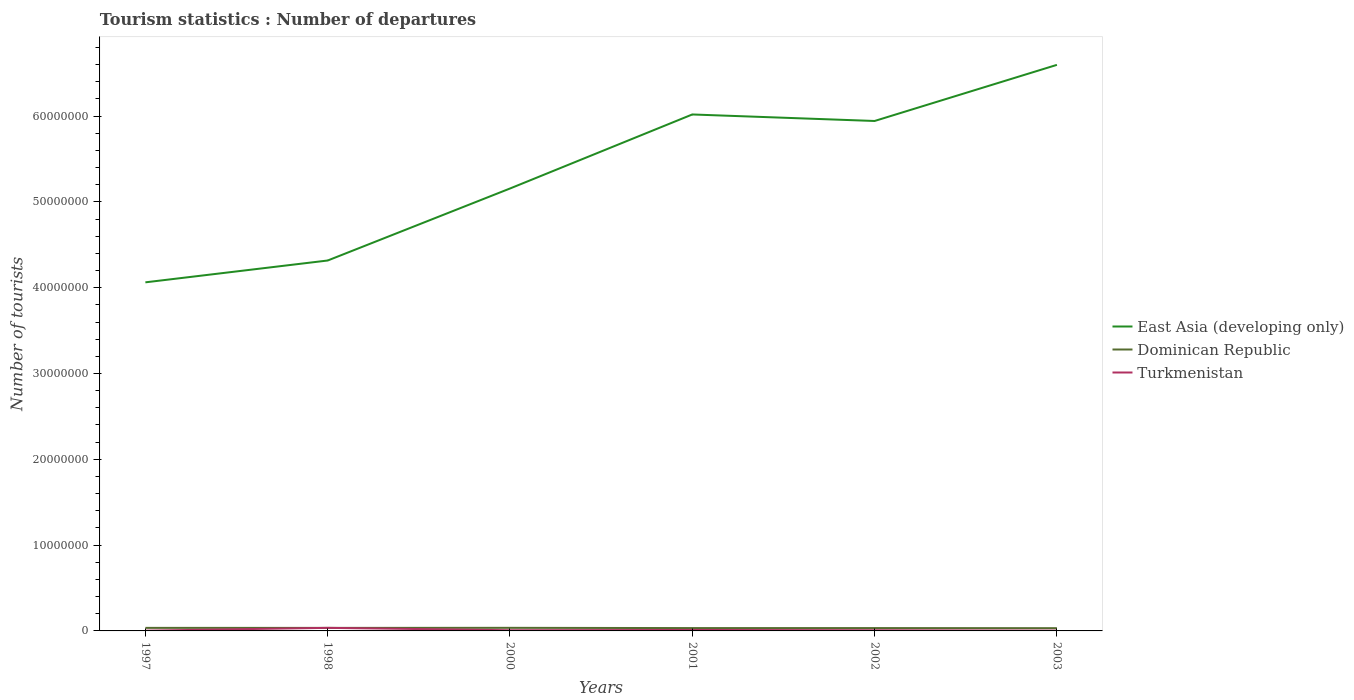Across all years, what is the maximum number of tourist departures in Turkmenistan?
Ensure brevity in your answer.  3.10e+04. What is the total number of tourist departures in East Asia (developing only) in the graph?
Offer a very short reply. -8.63e+06. What is the difference between the highest and the second highest number of tourist departures in Dominican Republic?
Offer a very short reply. 3.90e+04. What is the difference between the highest and the lowest number of tourist departures in East Asia (developing only)?
Your answer should be very brief. 3. What is the difference between two consecutive major ticks on the Y-axis?
Your answer should be very brief. 1.00e+07. Where does the legend appear in the graph?
Make the answer very short. Center right. How many legend labels are there?
Ensure brevity in your answer.  3. What is the title of the graph?
Your response must be concise. Tourism statistics : Number of departures. Does "West Bank and Gaza" appear as one of the legend labels in the graph?
Ensure brevity in your answer.  No. What is the label or title of the X-axis?
Your answer should be very brief. Years. What is the label or title of the Y-axis?
Your answer should be compact. Number of tourists. What is the Number of tourists of East Asia (developing only) in 1997?
Your response must be concise. 4.06e+07. What is the Number of tourists of Dominican Republic in 1997?
Your response must be concise. 3.55e+05. What is the Number of tourists of Turkmenistan in 1997?
Your answer should be very brief. 3.10e+04. What is the Number of tourists in East Asia (developing only) in 1998?
Your answer should be compact. 4.32e+07. What is the Number of tourists in Dominican Republic in 1998?
Offer a terse response. 3.54e+05. What is the Number of tourists of Turkmenistan in 1998?
Give a very brief answer. 3.57e+05. What is the Number of tourists in East Asia (developing only) in 2000?
Ensure brevity in your answer.  5.16e+07. What is the Number of tourists of Turkmenistan in 2000?
Give a very brief answer. 7.80e+04. What is the Number of tourists of East Asia (developing only) in 2001?
Offer a very short reply. 6.02e+07. What is the Number of tourists of Dominican Republic in 2001?
Give a very brief answer. 3.31e+05. What is the Number of tourists of Turkmenistan in 2001?
Your response must be concise. 1.11e+05. What is the Number of tourists in East Asia (developing only) in 2002?
Offer a terse response. 5.94e+07. What is the Number of tourists of Dominican Republic in 2002?
Your answer should be compact. 3.32e+05. What is the Number of tourists of Turkmenistan in 2002?
Give a very brief answer. 7.90e+04. What is the Number of tourists in East Asia (developing only) in 2003?
Your answer should be very brief. 6.60e+07. What is the Number of tourists of Dominican Republic in 2003?
Keep it short and to the point. 3.21e+05. What is the Number of tourists of Turkmenistan in 2003?
Your answer should be compact. 3.40e+04. Across all years, what is the maximum Number of tourists of East Asia (developing only)?
Keep it short and to the point. 6.60e+07. Across all years, what is the maximum Number of tourists of Dominican Republic?
Offer a very short reply. 3.60e+05. Across all years, what is the maximum Number of tourists of Turkmenistan?
Give a very brief answer. 3.57e+05. Across all years, what is the minimum Number of tourists of East Asia (developing only)?
Ensure brevity in your answer.  4.06e+07. Across all years, what is the minimum Number of tourists in Dominican Republic?
Ensure brevity in your answer.  3.21e+05. Across all years, what is the minimum Number of tourists in Turkmenistan?
Keep it short and to the point. 3.10e+04. What is the total Number of tourists of East Asia (developing only) in the graph?
Make the answer very short. 3.21e+08. What is the total Number of tourists in Dominican Republic in the graph?
Your response must be concise. 2.05e+06. What is the total Number of tourists of Turkmenistan in the graph?
Give a very brief answer. 6.90e+05. What is the difference between the Number of tourists in East Asia (developing only) in 1997 and that in 1998?
Offer a terse response. -2.54e+06. What is the difference between the Number of tourists in Turkmenistan in 1997 and that in 1998?
Offer a terse response. -3.26e+05. What is the difference between the Number of tourists of East Asia (developing only) in 1997 and that in 2000?
Provide a short and direct response. -1.09e+07. What is the difference between the Number of tourists in Dominican Republic in 1997 and that in 2000?
Give a very brief answer. -5000. What is the difference between the Number of tourists of Turkmenistan in 1997 and that in 2000?
Make the answer very short. -4.70e+04. What is the difference between the Number of tourists in East Asia (developing only) in 1997 and that in 2001?
Make the answer very short. -1.96e+07. What is the difference between the Number of tourists of Dominican Republic in 1997 and that in 2001?
Your response must be concise. 2.40e+04. What is the difference between the Number of tourists of Turkmenistan in 1997 and that in 2001?
Your answer should be very brief. -8.00e+04. What is the difference between the Number of tourists in East Asia (developing only) in 1997 and that in 2002?
Your answer should be very brief. -1.88e+07. What is the difference between the Number of tourists in Dominican Republic in 1997 and that in 2002?
Your response must be concise. 2.30e+04. What is the difference between the Number of tourists of Turkmenistan in 1997 and that in 2002?
Ensure brevity in your answer.  -4.80e+04. What is the difference between the Number of tourists of East Asia (developing only) in 1997 and that in 2003?
Your response must be concise. -2.53e+07. What is the difference between the Number of tourists in Dominican Republic in 1997 and that in 2003?
Ensure brevity in your answer.  3.40e+04. What is the difference between the Number of tourists in Turkmenistan in 1997 and that in 2003?
Ensure brevity in your answer.  -3000. What is the difference between the Number of tourists in East Asia (developing only) in 1998 and that in 2000?
Offer a very short reply. -8.39e+06. What is the difference between the Number of tourists in Dominican Republic in 1998 and that in 2000?
Your answer should be compact. -6000. What is the difference between the Number of tourists of Turkmenistan in 1998 and that in 2000?
Offer a very short reply. 2.79e+05. What is the difference between the Number of tourists in East Asia (developing only) in 1998 and that in 2001?
Provide a succinct answer. -1.70e+07. What is the difference between the Number of tourists in Dominican Republic in 1998 and that in 2001?
Give a very brief answer. 2.30e+04. What is the difference between the Number of tourists of Turkmenistan in 1998 and that in 2001?
Your response must be concise. 2.46e+05. What is the difference between the Number of tourists in East Asia (developing only) in 1998 and that in 2002?
Keep it short and to the point. -1.63e+07. What is the difference between the Number of tourists of Dominican Republic in 1998 and that in 2002?
Your answer should be compact. 2.20e+04. What is the difference between the Number of tourists of Turkmenistan in 1998 and that in 2002?
Make the answer very short. 2.78e+05. What is the difference between the Number of tourists in East Asia (developing only) in 1998 and that in 2003?
Keep it short and to the point. -2.28e+07. What is the difference between the Number of tourists in Dominican Republic in 1998 and that in 2003?
Ensure brevity in your answer.  3.30e+04. What is the difference between the Number of tourists in Turkmenistan in 1998 and that in 2003?
Your response must be concise. 3.23e+05. What is the difference between the Number of tourists of East Asia (developing only) in 2000 and that in 2001?
Offer a terse response. -8.63e+06. What is the difference between the Number of tourists in Dominican Republic in 2000 and that in 2001?
Your response must be concise. 2.90e+04. What is the difference between the Number of tourists of Turkmenistan in 2000 and that in 2001?
Your answer should be compact. -3.30e+04. What is the difference between the Number of tourists of East Asia (developing only) in 2000 and that in 2002?
Offer a terse response. -7.87e+06. What is the difference between the Number of tourists of Dominican Republic in 2000 and that in 2002?
Your answer should be very brief. 2.80e+04. What is the difference between the Number of tourists of Turkmenistan in 2000 and that in 2002?
Your answer should be very brief. -1000. What is the difference between the Number of tourists of East Asia (developing only) in 2000 and that in 2003?
Your response must be concise. -1.44e+07. What is the difference between the Number of tourists in Dominican Republic in 2000 and that in 2003?
Keep it short and to the point. 3.90e+04. What is the difference between the Number of tourists of Turkmenistan in 2000 and that in 2003?
Ensure brevity in your answer.  4.40e+04. What is the difference between the Number of tourists of East Asia (developing only) in 2001 and that in 2002?
Offer a very short reply. 7.60e+05. What is the difference between the Number of tourists in Dominican Republic in 2001 and that in 2002?
Give a very brief answer. -1000. What is the difference between the Number of tourists of Turkmenistan in 2001 and that in 2002?
Provide a succinct answer. 3.20e+04. What is the difference between the Number of tourists in East Asia (developing only) in 2001 and that in 2003?
Ensure brevity in your answer.  -5.78e+06. What is the difference between the Number of tourists in Turkmenistan in 2001 and that in 2003?
Provide a succinct answer. 7.70e+04. What is the difference between the Number of tourists of East Asia (developing only) in 2002 and that in 2003?
Ensure brevity in your answer.  -6.54e+06. What is the difference between the Number of tourists of Dominican Republic in 2002 and that in 2003?
Ensure brevity in your answer.  1.10e+04. What is the difference between the Number of tourists of Turkmenistan in 2002 and that in 2003?
Provide a short and direct response. 4.50e+04. What is the difference between the Number of tourists in East Asia (developing only) in 1997 and the Number of tourists in Dominican Republic in 1998?
Provide a succinct answer. 4.03e+07. What is the difference between the Number of tourists of East Asia (developing only) in 1997 and the Number of tourists of Turkmenistan in 1998?
Your answer should be very brief. 4.03e+07. What is the difference between the Number of tourists in Dominican Republic in 1997 and the Number of tourists in Turkmenistan in 1998?
Ensure brevity in your answer.  -2000. What is the difference between the Number of tourists of East Asia (developing only) in 1997 and the Number of tourists of Dominican Republic in 2000?
Give a very brief answer. 4.03e+07. What is the difference between the Number of tourists of East Asia (developing only) in 1997 and the Number of tourists of Turkmenistan in 2000?
Provide a succinct answer. 4.05e+07. What is the difference between the Number of tourists of Dominican Republic in 1997 and the Number of tourists of Turkmenistan in 2000?
Offer a very short reply. 2.77e+05. What is the difference between the Number of tourists in East Asia (developing only) in 1997 and the Number of tourists in Dominican Republic in 2001?
Ensure brevity in your answer.  4.03e+07. What is the difference between the Number of tourists in East Asia (developing only) in 1997 and the Number of tourists in Turkmenistan in 2001?
Keep it short and to the point. 4.05e+07. What is the difference between the Number of tourists of Dominican Republic in 1997 and the Number of tourists of Turkmenistan in 2001?
Your answer should be very brief. 2.44e+05. What is the difference between the Number of tourists of East Asia (developing only) in 1997 and the Number of tourists of Dominican Republic in 2002?
Provide a succinct answer. 4.03e+07. What is the difference between the Number of tourists of East Asia (developing only) in 1997 and the Number of tourists of Turkmenistan in 2002?
Your response must be concise. 4.05e+07. What is the difference between the Number of tourists in Dominican Republic in 1997 and the Number of tourists in Turkmenistan in 2002?
Keep it short and to the point. 2.76e+05. What is the difference between the Number of tourists in East Asia (developing only) in 1997 and the Number of tourists in Dominican Republic in 2003?
Your answer should be compact. 4.03e+07. What is the difference between the Number of tourists of East Asia (developing only) in 1997 and the Number of tourists of Turkmenistan in 2003?
Keep it short and to the point. 4.06e+07. What is the difference between the Number of tourists of Dominican Republic in 1997 and the Number of tourists of Turkmenistan in 2003?
Give a very brief answer. 3.21e+05. What is the difference between the Number of tourists of East Asia (developing only) in 1998 and the Number of tourists of Dominican Republic in 2000?
Your response must be concise. 4.28e+07. What is the difference between the Number of tourists in East Asia (developing only) in 1998 and the Number of tourists in Turkmenistan in 2000?
Offer a very short reply. 4.31e+07. What is the difference between the Number of tourists of Dominican Republic in 1998 and the Number of tourists of Turkmenistan in 2000?
Provide a succinct answer. 2.76e+05. What is the difference between the Number of tourists in East Asia (developing only) in 1998 and the Number of tourists in Dominican Republic in 2001?
Give a very brief answer. 4.28e+07. What is the difference between the Number of tourists in East Asia (developing only) in 1998 and the Number of tourists in Turkmenistan in 2001?
Your answer should be compact. 4.31e+07. What is the difference between the Number of tourists in Dominican Republic in 1998 and the Number of tourists in Turkmenistan in 2001?
Provide a short and direct response. 2.43e+05. What is the difference between the Number of tourists in East Asia (developing only) in 1998 and the Number of tourists in Dominican Republic in 2002?
Offer a very short reply. 4.28e+07. What is the difference between the Number of tourists in East Asia (developing only) in 1998 and the Number of tourists in Turkmenistan in 2002?
Keep it short and to the point. 4.31e+07. What is the difference between the Number of tourists in Dominican Republic in 1998 and the Number of tourists in Turkmenistan in 2002?
Offer a very short reply. 2.75e+05. What is the difference between the Number of tourists of East Asia (developing only) in 1998 and the Number of tourists of Dominican Republic in 2003?
Offer a very short reply. 4.28e+07. What is the difference between the Number of tourists in East Asia (developing only) in 1998 and the Number of tourists in Turkmenistan in 2003?
Ensure brevity in your answer.  4.31e+07. What is the difference between the Number of tourists of Dominican Republic in 1998 and the Number of tourists of Turkmenistan in 2003?
Give a very brief answer. 3.20e+05. What is the difference between the Number of tourists in East Asia (developing only) in 2000 and the Number of tourists in Dominican Republic in 2001?
Offer a very short reply. 5.12e+07. What is the difference between the Number of tourists in East Asia (developing only) in 2000 and the Number of tourists in Turkmenistan in 2001?
Offer a very short reply. 5.14e+07. What is the difference between the Number of tourists of Dominican Republic in 2000 and the Number of tourists of Turkmenistan in 2001?
Your answer should be very brief. 2.49e+05. What is the difference between the Number of tourists in East Asia (developing only) in 2000 and the Number of tourists in Dominican Republic in 2002?
Give a very brief answer. 5.12e+07. What is the difference between the Number of tourists of East Asia (developing only) in 2000 and the Number of tourists of Turkmenistan in 2002?
Ensure brevity in your answer.  5.15e+07. What is the difference between the Number of tourists in Dominican Republic in 2000 and the Number of tourists in Turkmenistan in 2002?
Provide a succinct answer. 2.81e+05. What is the difference between the Number of tourists of East Asia (developing only) in 2000 and the Number of tourists of Dominican Republic in 2003?
Ensure brevity in your answer.  5.12e+07. What is the difference between the Number of tourists in East Asia (developing only) in 2000 and the Number of tourists in Turkmenistan in 2003?
Make the answer very short. 5.15e+07. What is the difference between the Number of tourists of Dominican Republic in 2000 and the Number of tourists of Turkmenistan in 2003?
Keep it short and to the point. 3.26e+05. What is the difference between the Number of tourists in East Asia (developing only) in 2001 and the Number of tourists in Dominican Republic in 2002?
Provide a succinct answer. 5.99e+07. What is the difference between the Number of tourists of East Asia (developing only) in 2001 and the Number of tourists of Turkmenistan in 2002?
Keep it short and to the point. 6.01e+07. What is the difference between the Number of tourists of Dominican Republic in 2001 and the Number of tourists of Turkmenistan in 2002?
Offer a very short reply. 2.52e+05. What is the difference between the Number of tourists of East Asia (developing only) in 2001 and the Number of tourists of Dominican Republic in 2003?
Give a very brief answer. 5.99e+07. What is the difference between the Number of tourists in East Asia (developing only) in 2001 and the Number of tourists in Turkmenistan in 2003?
Your answer should be compact. 6.02e+07. What is the difference between the Number of tourists of Dominican Republic in 2001 and the Number of tourists of Turkmenistan in 2003?
Offer a terse response. 2.97e+05. What is the difference between the Number of tourists in East Asia (developing only) in 2002 and the Number of tourists in Dominican Republic in 2003?
Offer a very short reply. 5.91e+07. What is the difference between the Number of tourists in East Asia (developing only) in 2002 and the Number of tourists in Turkmenistan in 2003?
Your answer should be very brief. 5.94e+07. What is the difference between the Number of tourists of Dominican Republic in 2002 and the Number of tourists of Turkmenistan in 2003?
Provide a short and direct response. 2.98e+05. What is the average Number of tourists in East Asia (developing only) per year?
Make the answer very short. 5.35e+07. What is the average Number of tourists of Dominican Republic per year?
Make the answer very short. 3.42e+05. What is the average Number of tourists in Turkmenistan per year?
Your response must be concise. 1.15e+05. In the year 1997, what is the difference between the Number of tourists of East Asia (developing only) and Number of tourists of Dominican Republic?
Give a very brief answer. 4.03e+07. In the year 1997, what is the difference between the Number of tourists of East Asia (developing only) and Number of tourists of Turkmenistan?
Your response must be concise. 4.06e+07. In the year 1997, what is the difference between the Number of tourists of Dominican Republic and Number of tourists of Turkmenistan?
Offer a terse response. 3.24e+05. In the year 1998, what is the difference between the Number of tourists in East Asia (developing only) and Number of tourists in Dominican Republic?
Keep it short and to the point. 4.28e+07. In the year 1998, what is the difference between the Number of tourists of East Asia (developing only) and Number of tourists of Turkmenistan?
Provide a short and direct response. 4.28e+07. In the year 1998, what is the difference between the Number of tourists of Dominican Republic and Number of tourists of Turkmenistan?
Your answer should be very brief. -3000. In the year 2000, what is the difference between the Number of tourists in East Asia (developing only) and Number of tourists in Dominican Republic?
Make the answer very short. 5.12e+07. In the year 2000, what is the difference between the Number of tourists of East Asia (developing only) and Number of tourists of Turkmenistan?
Offer a terse response. 5.15e+07. In the year 2000, what is the difference between the Number of tourists of Dominican Republic and Number of tourists of Turkmenistan?
Ensure brevity in your answer.  2.82e+05. In the year 2001, what is the difference between the Number of tourists of East Asia (developing only) and Number of tourists of Dominican Republic?
Offer a terse response. 5.99e+07. In the year 2001, what is the difference between the Number of tourists in East Asia (developing only) and Number of tourists in Turkmenistan?
Your answer should be compact. 6.01e+07. In the year 2002, what is the difference between the Number of tourists in East Asia (developing only) and Number of tourists in Dominican Republic?
Provide a short and direct response. 5.91e+07. In the year 2002, what is the difference between the Number of tourists in East Asia (developing only) and Number of tourists in Turkmenistan?
Give a very brief answer. 5.93e+07. In the year 2002, what is the difference between the Number of tourists in Dominican Republic and Number of tourists in Turkmenistan?
Offer a terse response. 2.53e+05. In the year 2003, what is the difference between the Number of tourists of East Asia (developing only) and Number of tourists of Dominican Republic?
Make the answer very short. 6.56e+07. In the year 2003, what is the difference between the Number of tourists of East Asia (developing only) and Number of tourists of Turkmenistan?
Keep it short and to the point. 6.59e+07. In the year 2003, what is the difference between the Number of tourists in Dominican Republic and Number of tourists in Turkmenistan?
Your answer should be very brief. 2.87e+05. What is the ratio of the Number of tourists in East Asia (developing only) in 1997 to that in 1998?
Give a very brief answer. 0.94. What is the ratio of the Number of tourists in Dominican Republic in 1997 to that in 1998?
Keep it short and to the point. 1. What is the ratio of the Number of tourists of Turkmenistan in 1997 to that in 1998?
Ensure brevity in your answer.  0.09. What is the ratio of the Number of tourists of East Asia (developing only) in 1997 to that in 2000?
Offer a very short reply. 0.79. What is the ratio of the Number of tourists of Dominican Republic in 1997 to that in 2000?
Provide a short and direct response. 0.99. What is the ratio of the Number of tourists of Turkmenistan in 1997 to that in 2000?
Provide a succinct answer. 0.4. What is the ratio of the Number of tourists of East Asia (developing only) in 1997 to that in 2001?
Your answer should be very brief. 0.68. What is the ratio of the Number of tourists in Dominican Republic in 1997 to that in 2001?
Provide a succinct answer. 1.07. What is the ratio of the Number of tourists in Turkmenistan in 1997 to that in 2001?
Offer a very short reply. 0.28. What is the ratio of the Number of tourists of East Asia (developing only) in 1997 to that in 2002?
Ensure brevity in your answer.  0.68. What is the ratio of the Number of tourists in Dominican Republic in 1997 to that in 2002?
Your answer should be compact. 1.07. What is the ratio of the Number of tourists in Turkmenistan in 1997 to that in 2002?
Provide a short and direct response. 0.39. What is the ratio of the Number of tourists in East Asia (developing only) in 1997 to that in 2003?
Your response must be concise. 0.62. What is the ratio of the Number of tourists of Dominican Republic in 1997 to that in 2003?
Your answer should be compact. 1.11. What is the ratio of the Number of tourists of Turkmenistan in 1997 to that in 2003?
Provide a succinct answer. 0.91. What is the ratio of the Number of tourists in East Asia (developing only) in 1998 to that in 2000?
Offer a terse response. 0.84. What is the ratio of the Number of tourists of Dominican Republic in 1998 to that in 2000?
Provide a short and direct response. 0.98. What is the ratio of the Number of tourists of Turkmenistan in 1998 to that in 2000?
Provide a short and direct response. 4.58. What is the ratio of the Number of tourists in East Asia (developing only) in 1998 to that in 2001?
Your answer should be compact. 0.72. What is the ratio of the Number of tourists in Dominican Republic in 1998 to that in 2001?
Your answer should be very brief. 1.07. What is the ratio of the Number of tourists of Turkmenistan in 1998 to that in 2001?
Make the answer very short. 3.22. What is the ratio of the Number of tourists in East Asia (developing only) in 1998 to that in 2002?
Your answer should be compact. 0.73. What is the ratio of the Number of tourists in Dominican Republic in 1998 to that in 2002?
Ensure brevity in your answer.  1.07. What is the ratio of the Number of tourists in Turkmenistan in 1998 to that in 2002?
Provide a short and direct response. 4.52. What is the ratio of the Number of tourists in East Asia (developing only) in 1998 to that in 2003?
Your answer should be very brief. 0.65. What is the ratio of the Number of tourists in Dominican Republic in 1998 to that in 2003?
Provide a succinct answer. 1.1. What is the ratio of the Number of tourists in Turkmenistan in 1998 to that in 2003?
Your response must be concise. 10.5. What is the ratio of the Number of tourists in East Asia (developing only) in 2000 to that in 2001?
Give a very brief answer. 0.86. What is the ratio of the Number of tourists of Dominican Republic in 2000 to that in 2001?
Give a very brief answer. 1.09. What is the ratio of the Number of tourists in Turkmenistan in 2000 to that in 2001?
Provide a succinct answer. 0.7. What is the ratio of the Number of tourists in East Asia (developing only) in 2000 to that in 2002?
Provide a short and direct response. 0.87. What is the ratio of the Number of tourists in Dominican Republic in 2000 to that in 2002?
Provide a short and direct response. 1.08. What is the ratio of the Number of tourists in Turkmenistan in 2000 to that in 2002?
Ensure brevity in your answer.  0.99. What is the ratio of the Number of tourists of East Asia (developing only) in 2000 to that in 2003?
Offer a very short reply. 0.78. What is the ratio of the Number of tourists of Dominican Republic in 2000 to that in 2003?
Your answer should be very brief. 1.12. What is the ratio of the Number of tourists of Turkmenistan in 2000 to that in 2003?
Offer a terse response. 2.29. What is the ratio of the Number of tourists in East Asia (developing only) in 2001 to that in 2002?
Ensure brevity in your answer.  1.01. What is the ratio of the Number of tourists of Turkmenistan in 2001 to that in 2002?
Provide a succinct answer. 1.41. What is the ratio of the Number of tourists in East Asia (developing only) in 2001 to that in 2003?
Make the answer very short. 0.91. What is the ratio of the Number of tourists in Dominican Republic in 2001 to that in 2003?
Your answer should be compact. 1.03. What is the ratio of the Number of tourists of Turkmenistan in 2001 to that in 2003?
Your response must be concise. 3.26. What is the ratio of the Number of tourists in East Asia (developing only) in 2002 to that in 2003?
Offer a very short reply. 0.9. What is the ratio of the Number of tourists in Dominican Republic in 2002 to that in 2003?
Provide a succinct answer. 1.03. What is the ratio of the Number of tourists of Turkmenistan in 2002 to that in 2003?
Your answer should be compact. 2.32. What is the difference between the highest and the second highest Number of tourists of East Asia (developing only)?
Ensure brevity in your answer.  5.78e+06. What is the difference between the highest and the second highest Number of tourists in Turkmenistan?
Keep it short and to the point. 2.46e+05. What is the difference between the highest and the lowest Number of tourists of East Asia (developing only)?
Your response must be concise. 2.53e+07. What is the difference between the highest and the lowest Number of tourists in Dominican Republic?
Provide a short and direct response. 3.90e+04. What is the difference between the highest and the lowest Number of tourists of Turkmenistan?
Your answer should be compact. 3.26e+05. 